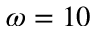<formula> <loc_0><loc_0><loc_500><loc_500>\omega = 1 0</formula> 